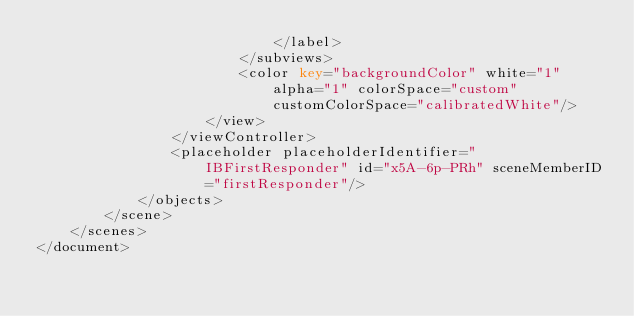Convert code to text. <code><loc_0><loc_0><loc_500><loc_500><_XML_>                            </label>
                        </subviews>
                        <color key="backgroundColor" white="1" alpha="1" colorSpace="custom" customColorSpace="calibratedWhite"/>
                    </view>
                </viewController>
                <placeholder placeholderIdentifier="IBFirstResponder" id="x5A-6p-PRh" sceneMemberID="firstResponder"/>
            </objects>
        </scene>
    </scenes>
</document>
</code> 